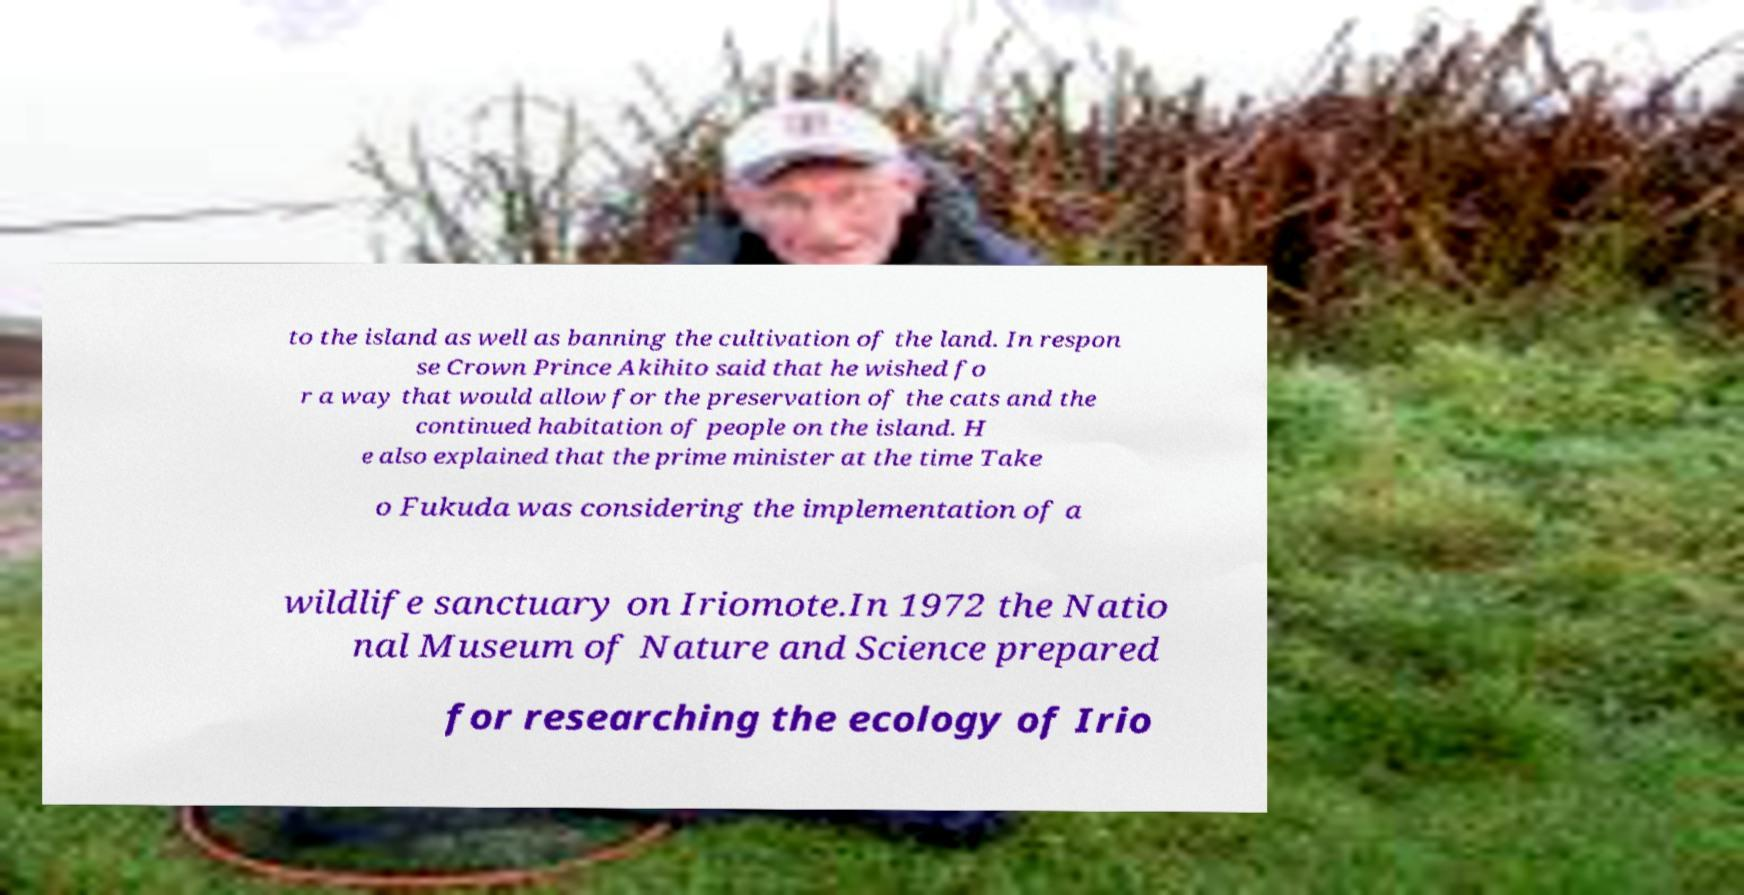Could you assist in decoding the text presented in this image and type it out clearly? to the island as well as banning the cultivation of the land. In respon se Crown Prince Akihito said that he wished fo r a way that would allow for the preservation of the cats and the continued habitation of people on the island. H e also explained that the prime minister at the time Take o Fukuda was considering the implementation of a wildlife sanctuary on Iriomote.In 1972 the Natio nal Museum of Nature and Science prepared for researching the ecology of Irio 